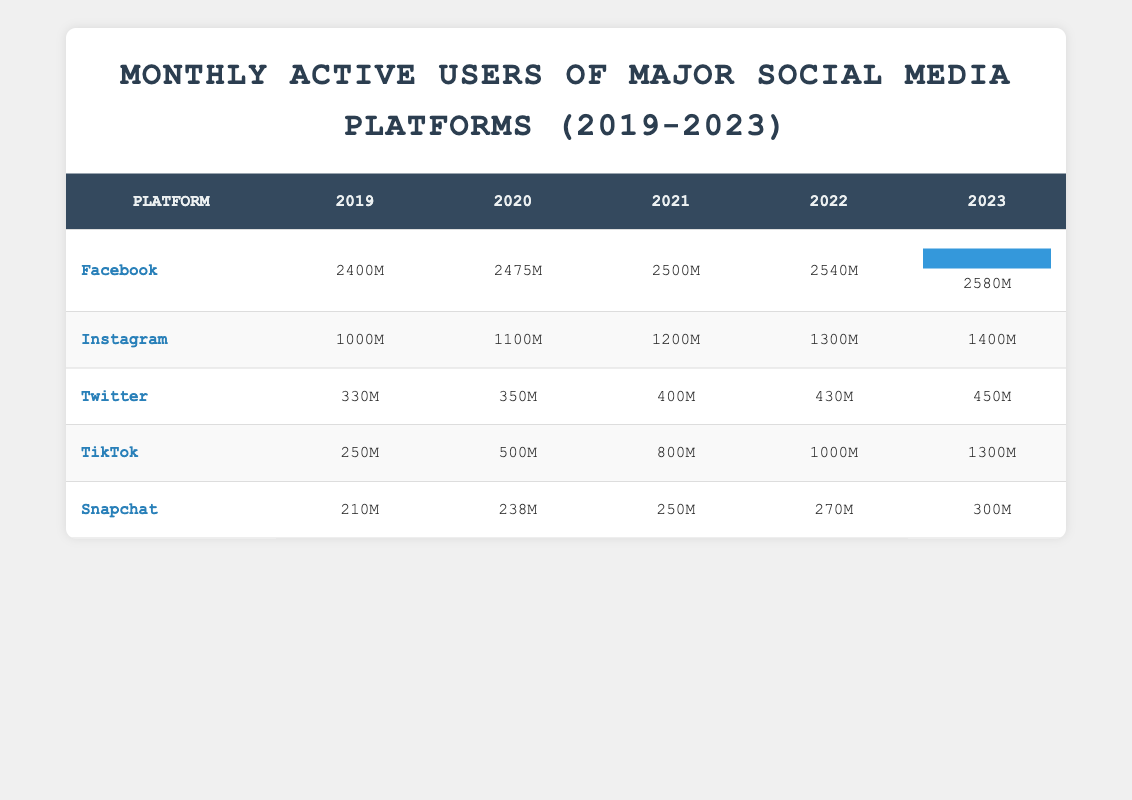What was the monthly active user count for Facebook in 2023? The table shows that Facebook had 2580 million monthly active users in 2023, as indicated in the 2023 column for Facebook.
Answer: 2580M Which platform had the highest growth in monthly active users from 2019 to 2023? To determine growth, we compare the user counts in 2019 and 2023 for each platform. Facebook had an increase from 2400M to 2580M (180M growth), Instagram from 1000M to 1400M (400M growth), Twitter from 330M to 450M (120M growth), TikTok from 250M to 1300M (1050M growth), and Snapchat from 210M to 300M (90M growth). TikTok had the highest growth with an increase of 1050M.
Answer: TikTok Did Instagram's monthly active users decline in any year during the observed period? A decline would mean that the user count in a particular year is less than that of the previous year. Checking the table: Instagram increased each year from 2019 (1000M) to 2023 (1400M); hence, there were no declines.
Answer: No Calculate the average monthly active users for Snapchat over the 5 years. Adding the users from 2019 to 2023 gives 210M + 238M + 250M + 270M + 300M = 1268M. Dividing by 5 (the number of years), the average is 1268M / 5 = 253.6M.
Answer: 253.6M Which platform had the fewest monthly active users in 2021? The table shows 2021 user counts: Facebook (2500M), Instagram (1200M), Twitter (400M), TikTok (800M), and Snapchat (250M). Snapchat had the lowest count at 250M in 2021.
Answer: Snapchat In which year did Twitter reach 400 million users? Looking at the table, Twitter reached 400 million monthly active users in 2021, as shown in the 2021 column.
Answer: 2021 Was there a year when Facebook's monthly active users were fewer than Instagram's? Comparing the counts, Facebook had 2400M in 2019 while Instagram had 1000M that year, and every subsequent year, Facebook's numbers exceeded Instagram's. Thus, there was no year when Facebook had fewer users than Instagram.
Answer: No What is the percentage increase in TikTok users from 2019 to 2023? TikTok had 250M users in 2019 and 1300M in 2023. The increase is 1300M - 250M = 1050M. To find the percentage increase: (1050M / 250M) * 100 = 420%.
Answer: 420% 